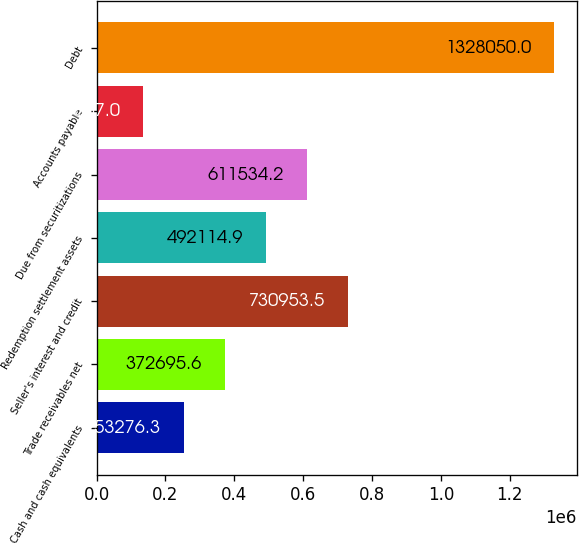Convert chart. <chart><loc_0><loc_0><loc_500><loc_500><bar_chart><fcel>Cash and cash equivalents<fcel>Trade receivables net<fcel>Seller's interest and credit<fcel>Redemption settlement assets<fcel>Due from securitizations<fcel>Accounts payable<fcel>Debt<nl><fcel>253276<fcel>372696<fcel>730954<fcel>492115<fcel>611534<fcel>133857<fcel>1.32805e+06<nl></chart> 